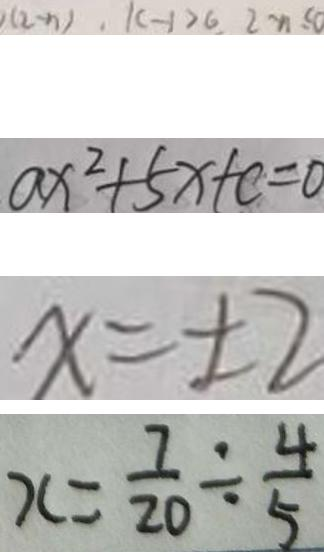<formula> <loc_0><loc_0><loc_500><loc_500>( 2 - n ) , k - 1 > 6 , 2 - n \leq 0 
 a x ^ { 2 } + 5 x + c = 0 
 x = \pm 2 
 x = \frac { 7 } { 2 0 } \div \frac { 4 } { 5 }</formula> 